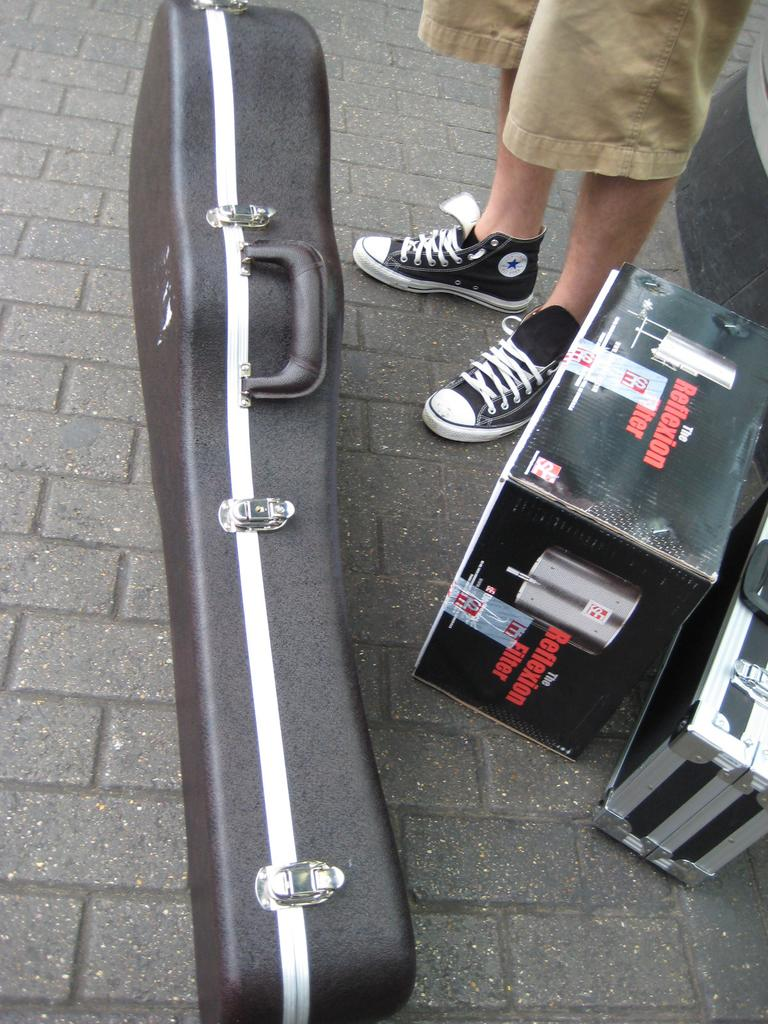What object is on the ground in the image? There is a guitar case on the ground in the image. What other objects can be seen in the image? There are two boxes in the image. Can you describe the person's legs visible in the image? A person's legs are visible in the top right corner of the image. What type of dock can be seen near the guitar case in the image? There is no dock present in the image; it only features a guitar case, two boxes, and a person's legs. What kind of boot is the person wearing on their left leg in the image? The image does not show the person's foot or any boots, only their legs are visible. 